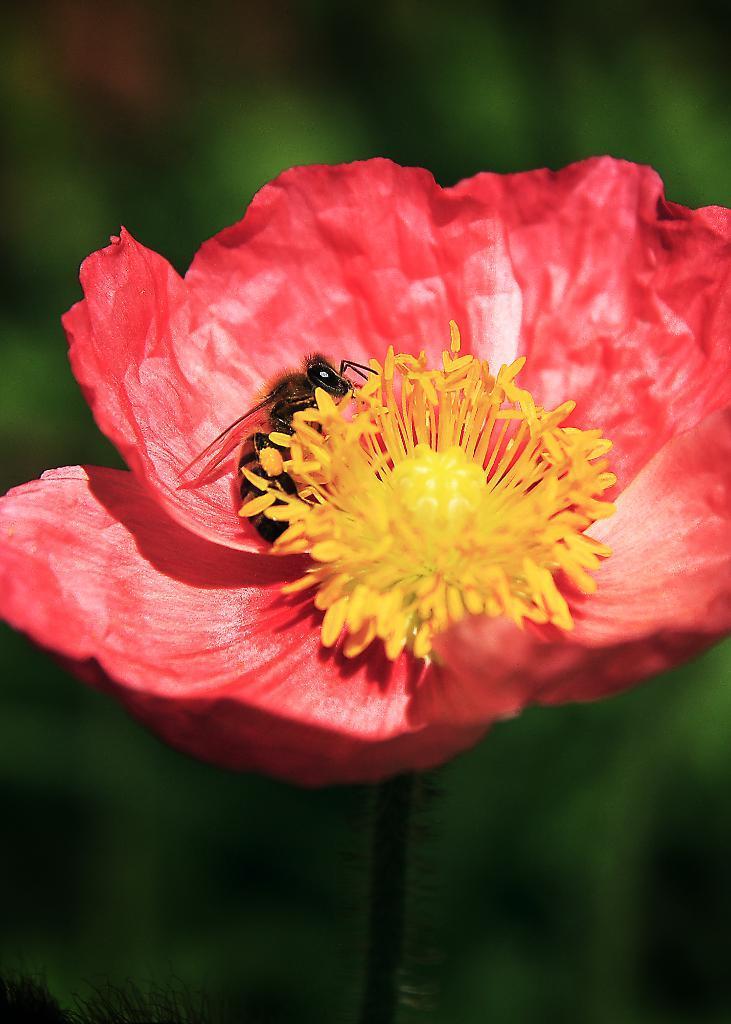Can you describe this image briefly? In the image there is a pink flower with a honey bee in it. And there is a blur background. 